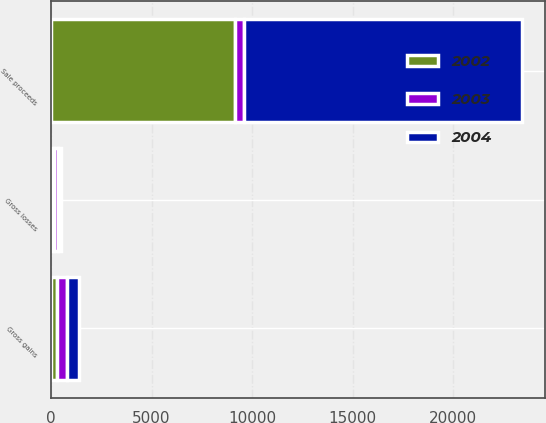<chart> <loc_0><loc_0><loc_500><loc_500><stacked_bar_chart><ecel><fcel>Sale proceeds<fcel>Gross gains<fcel>Gross losses<nl><fcel>2003<fcel>400.5<fcel>525<fcel>202<nl><fcel>2004<fcel>13827<fcel>576<fcel>150<nl><fcel>2002<fcel>9174<fcel>276<fcel>134<nl></chart> 